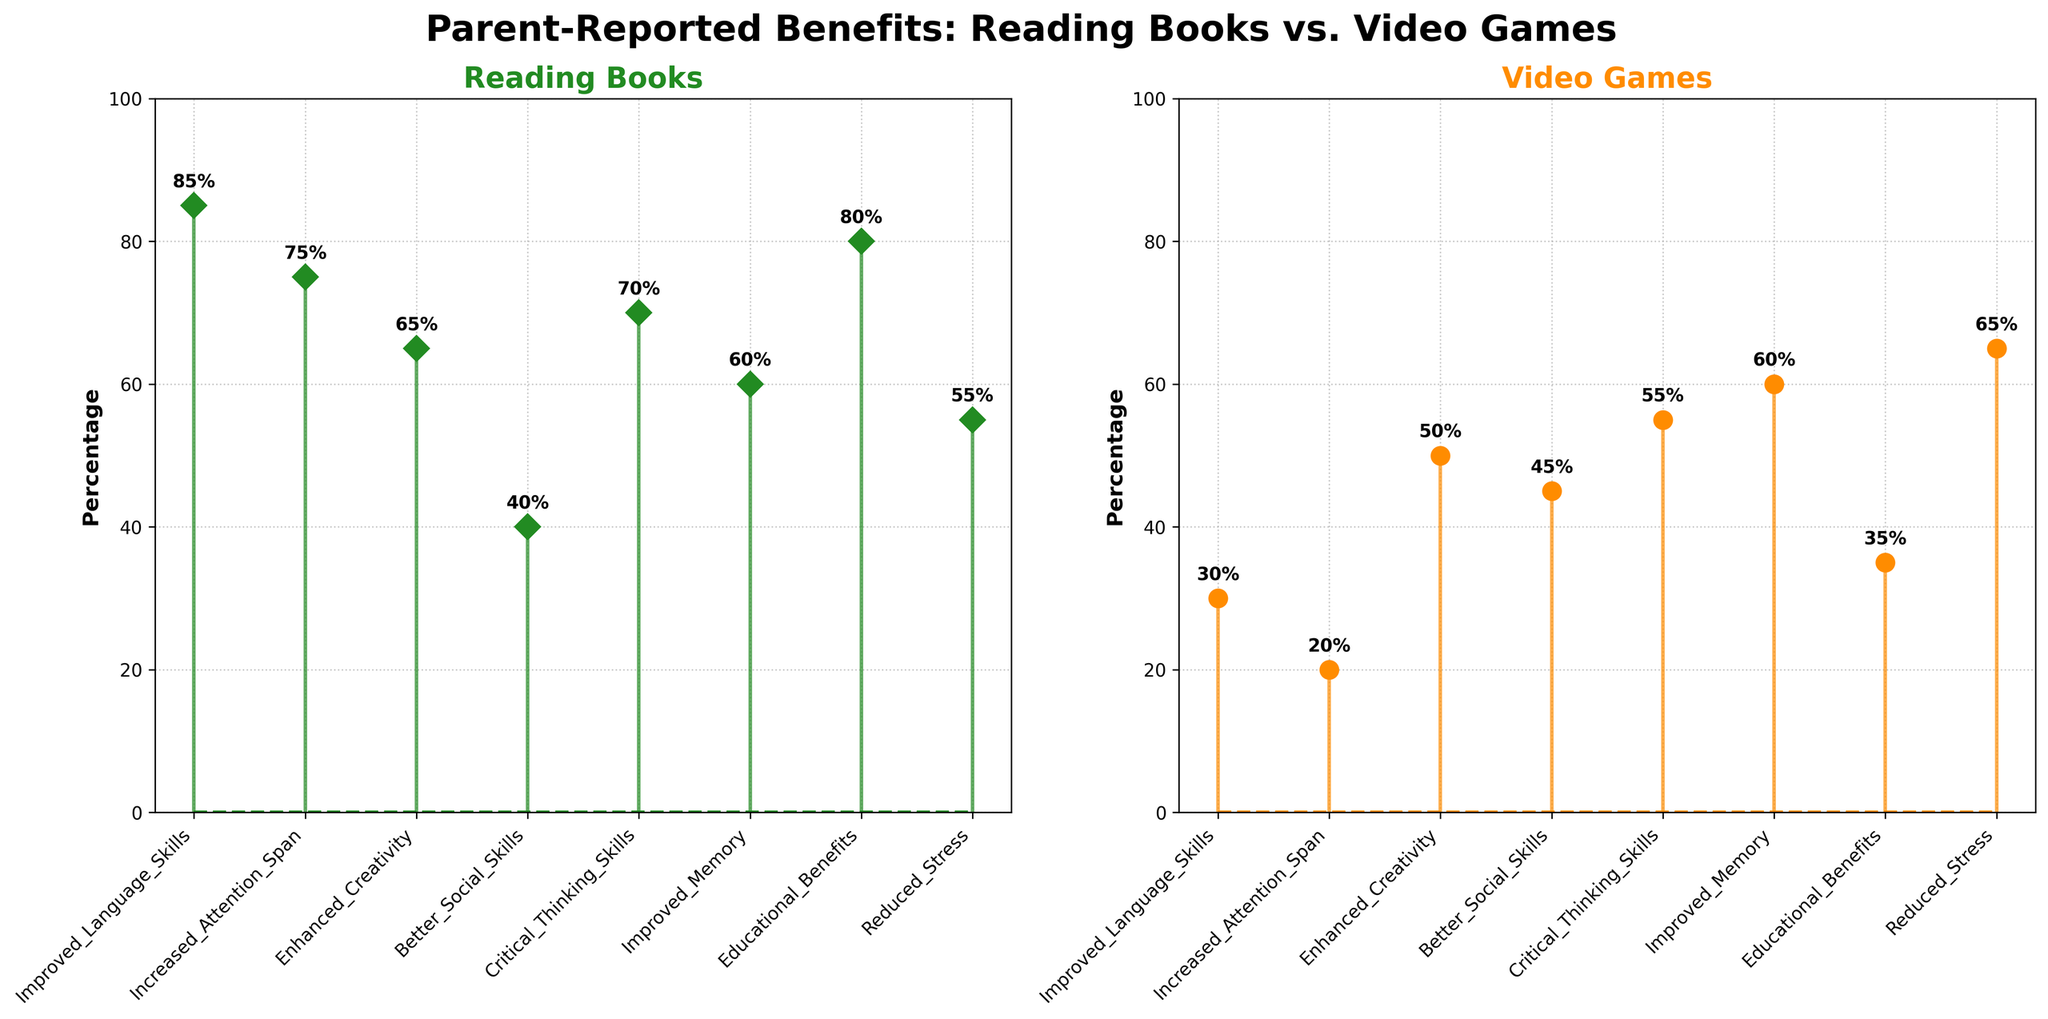What is the title of the figure? The title of the figure is written at the top and gives a broad idea about what the figure is showing.
Answer: "Parent-Reported Benefits: Reading Books vs. Video Games" What color is used for the stem lines representing Reading Books? The stem lines for Reading Books are colored in a distinct way to differentiate them from Video Games. They are in a dark shade of green.
Answer: Forest green Which activity has a higher percentage for "Improved Language Skills"? By comparing the stem height for "Improved Language Skills" on both subplots, one can see that Reading Books has a taller stem than Video Games for this benefit.
Answer: Reading Books How many benefits are reported in the figure? Count the number of unique benefits listed on the x-axis. Each one represents a different cognitive benefit reported by parents.
Answer: 8 What is the difference in percentage for "Educational Benefits" between Reading Books and Video Games? Look at the heights of the stems for "Educational Benefits" in both subplots. Reading Books shows a percentage of 80% and Video Games shows 35%. The difference is the subtraction of these values. 80% - 35% = 45%.
Answer: 45% Which benefit shows equal percentages for both activities? By examining each pair of stems across both subplots, one can find that "Improved Memory" has equal stem heights in both cases.
Answer: Improved Memory What is the average percentage of benefits reported for Video Games? Adding all the percentages reported for Video Games and then dividing by the number of benefits will give the average. (30 + 20 + 50 + 45 + 55 + 60 + 35 + 65) / 8 = 45%
Answer: 45% Which benefit shows the largest percentage for Reading Books? By identifying the tallest stem in the subplot for Reading Books, one can see that "Improved Language Skills" has the highest percentage at 85%.
Answer: Improved Language Skills For the benefit of "Reduced Stress," which activity has a higher reported benefit and by how much? Compare the stem heights for "Reduced Stress" in both subplots. Reading Books shows 55% and Video Games shows 65%. Video Games is higher. The difference is 65% - 55% = 10%.
Answer: Video Games by 10% Which activity has more benefits reported with percentages over 60%? Count the number of benefits with stems exceeding 60% in height for each activity, Reading Books and Video Games. Reading Books has 5 benefits over 60% while Video Games has only 3.
Answer: Reading Books 